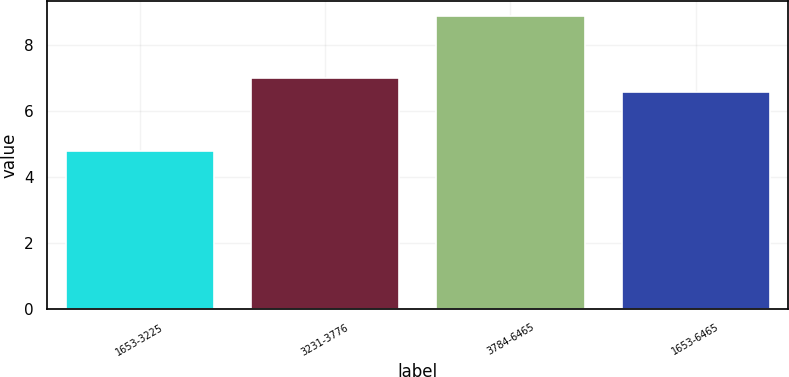Convert chart. <chart><loc_0><loc_0><loc_500><loc_500><bar_chart><fcel>1653-3225<fcel>3231-3776<fcel>3784-6465<fcel>1653-6465<nl><fcel>4.8<fcel>7.01<fcel>8.9<fcel>6.6<nl></chart> 